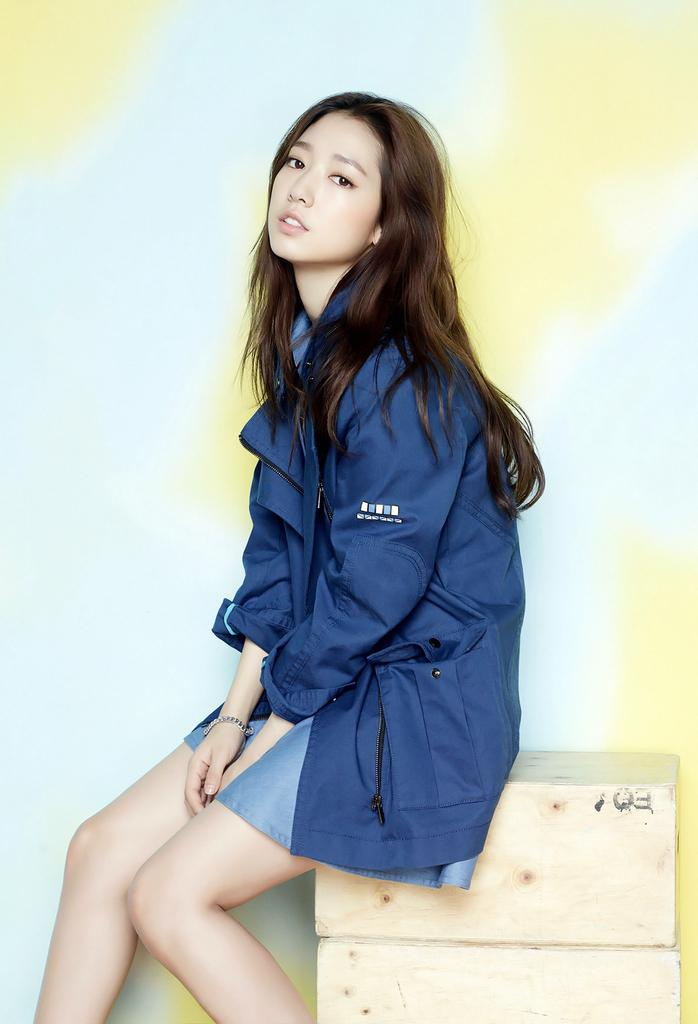Who is the main subject in the image? There is a woman in the image. What is the woman doing in the image? The woman is sitting on an object. What can be seen behind the woman in the image? There is a wall visible in the image behind the woman. What is the governor's opinion on the expansion of the woman's activities in the image? There is no mention of a governor or any expansion of activities in the image, so it is not possible to answer that question. 